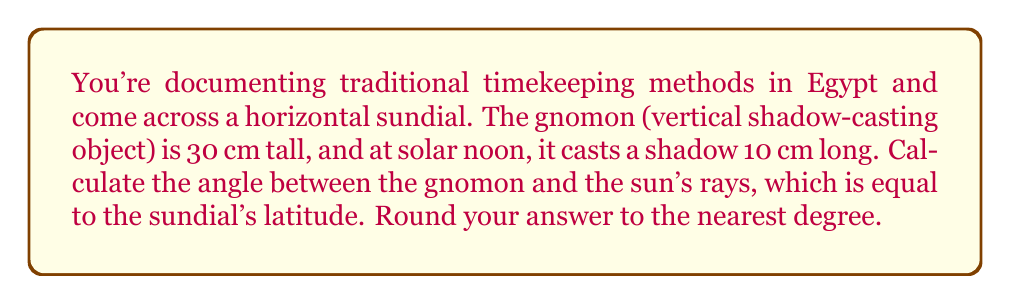Teach me how to tackle this problem. To solve this problem, we can use trigonometry. The gnomon and its shadow form a right triangle with the sun's rays.

1) Let's define our variables:
   $h$ = height of gnomon = 30 cm
   $s$ = length of shadow = 10 cm
   $\theta$ = angle between gnomon and sun's rays (also the latitude)

2) We can use the tangent function to find the angle:
   
   $$\tan(\theta) = \frac{\text{opposite}}{\text{adjacent}} = \frac{s}{h} = \frac{10}{30}$$

3) To find $\theta$, we take the inverse tangent (arctangent) of both sides:

   $$\theta = \arctan(\frac{10}{30})$$

4) Using a calculator or computer:

   $$\theta \approx 18.4349^\circ$$

5) Rounding to the nearest degree:

   $$\theta \approx 18^\circ$$

Thus, the angle between the gnomon and the sun's rays, which is equal to the sundial's latitude, is approximately 18°.
Answer: $18^\circ$ 